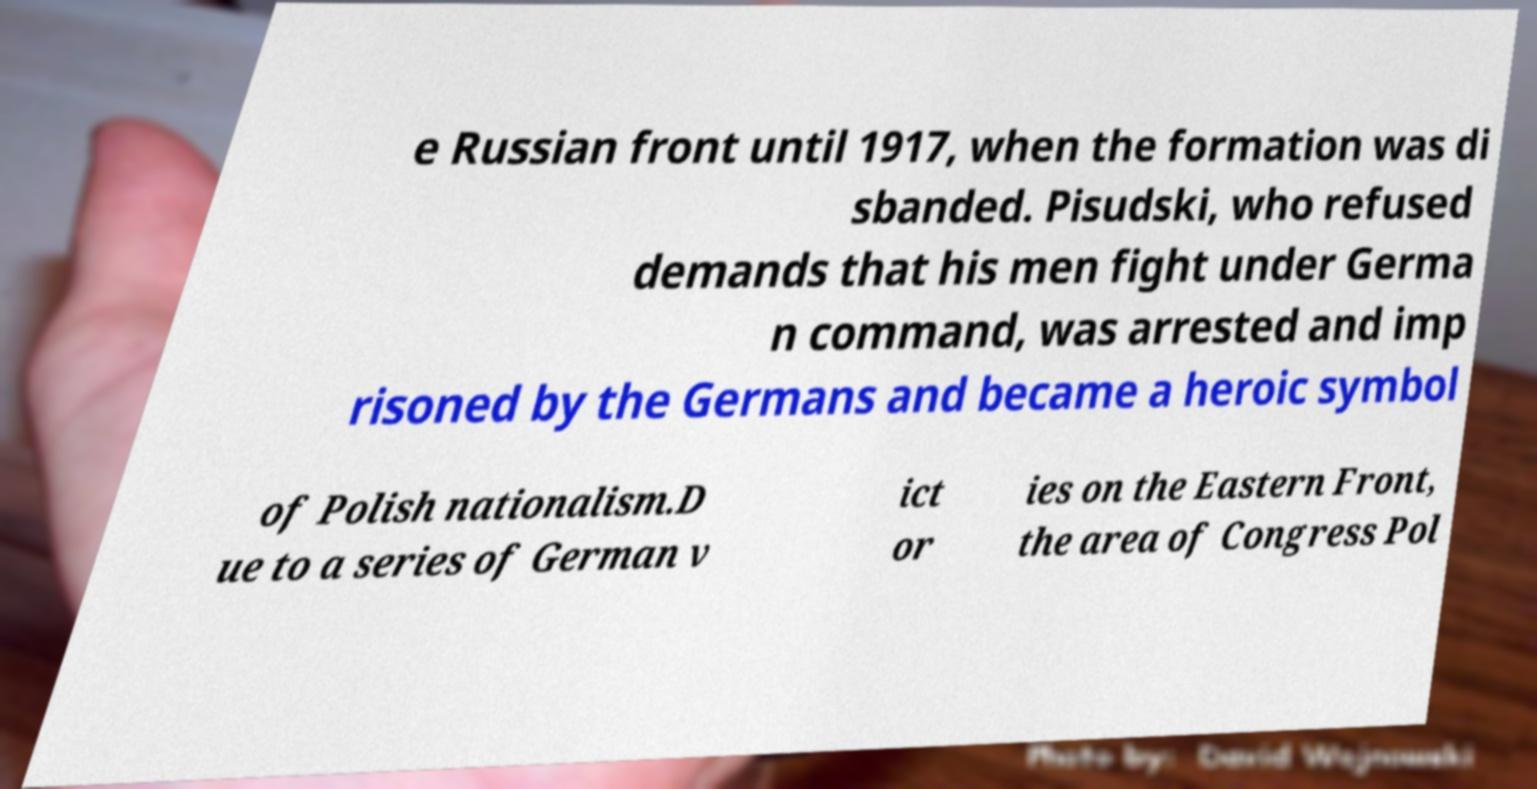There's text embedded in this image that I need extracted. Can you transcribe it verbatim? e Russian front until 1917, when the formation was di sbanded. Pisudski, who refused demands that his men fight under Germa n command, was arrested and imp risoned by the Germans and became a heroic symbol of Polish nationalism.D ue to a series of German v ict or ies on the Eastern Front, the area of Congress Pol 